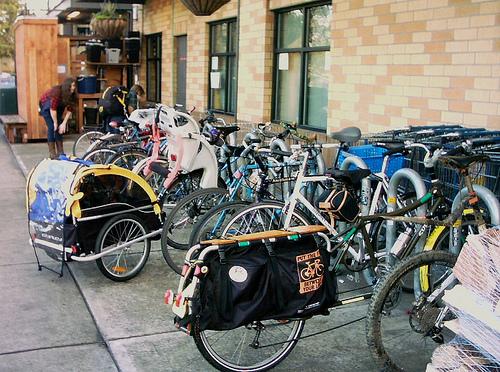Is this urban or suburban?
Be succinct. Urban. How many bikes are here?
Answer briefly. 10. How many people in this photo have long hair?
Answer briefly. 1. 